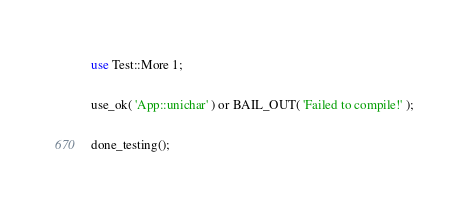Convert code to text. <code><loc_0><loc_0><loc_500><loc_500><_Perl_>use Test::More 1;

use_ok( 'App::unichar' ) or BAIL_OUT( 'Failed to compile!' );

done_testing();
</code> 